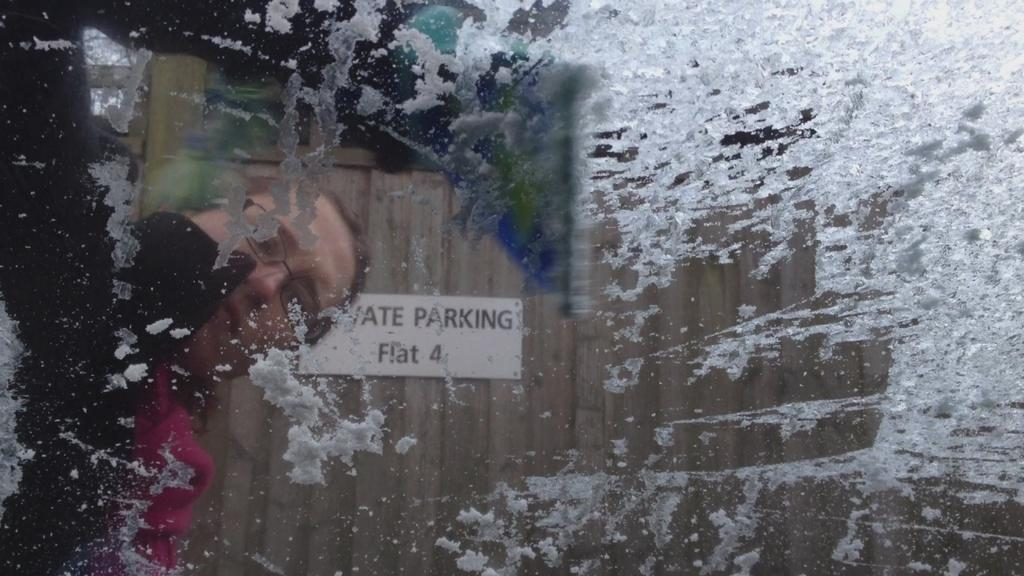What is inside the glass that is visible in the image? The glass contains snow. Can you describe the person in the background of the image? Unfortunately, the facts provided do not give any details about the person in the background. What type of material is the wall in the background of the image made of? The wall in the background of the image is made of wood. What is attached to the wooden wall? There is a board attached to the wooden wall. What is written on the board? There is text on the board. What type of summer clothing is the snow wearing in the image? The snow is not wearing any clothing, as it is an inanimate object and not capable of wearing clothing. 